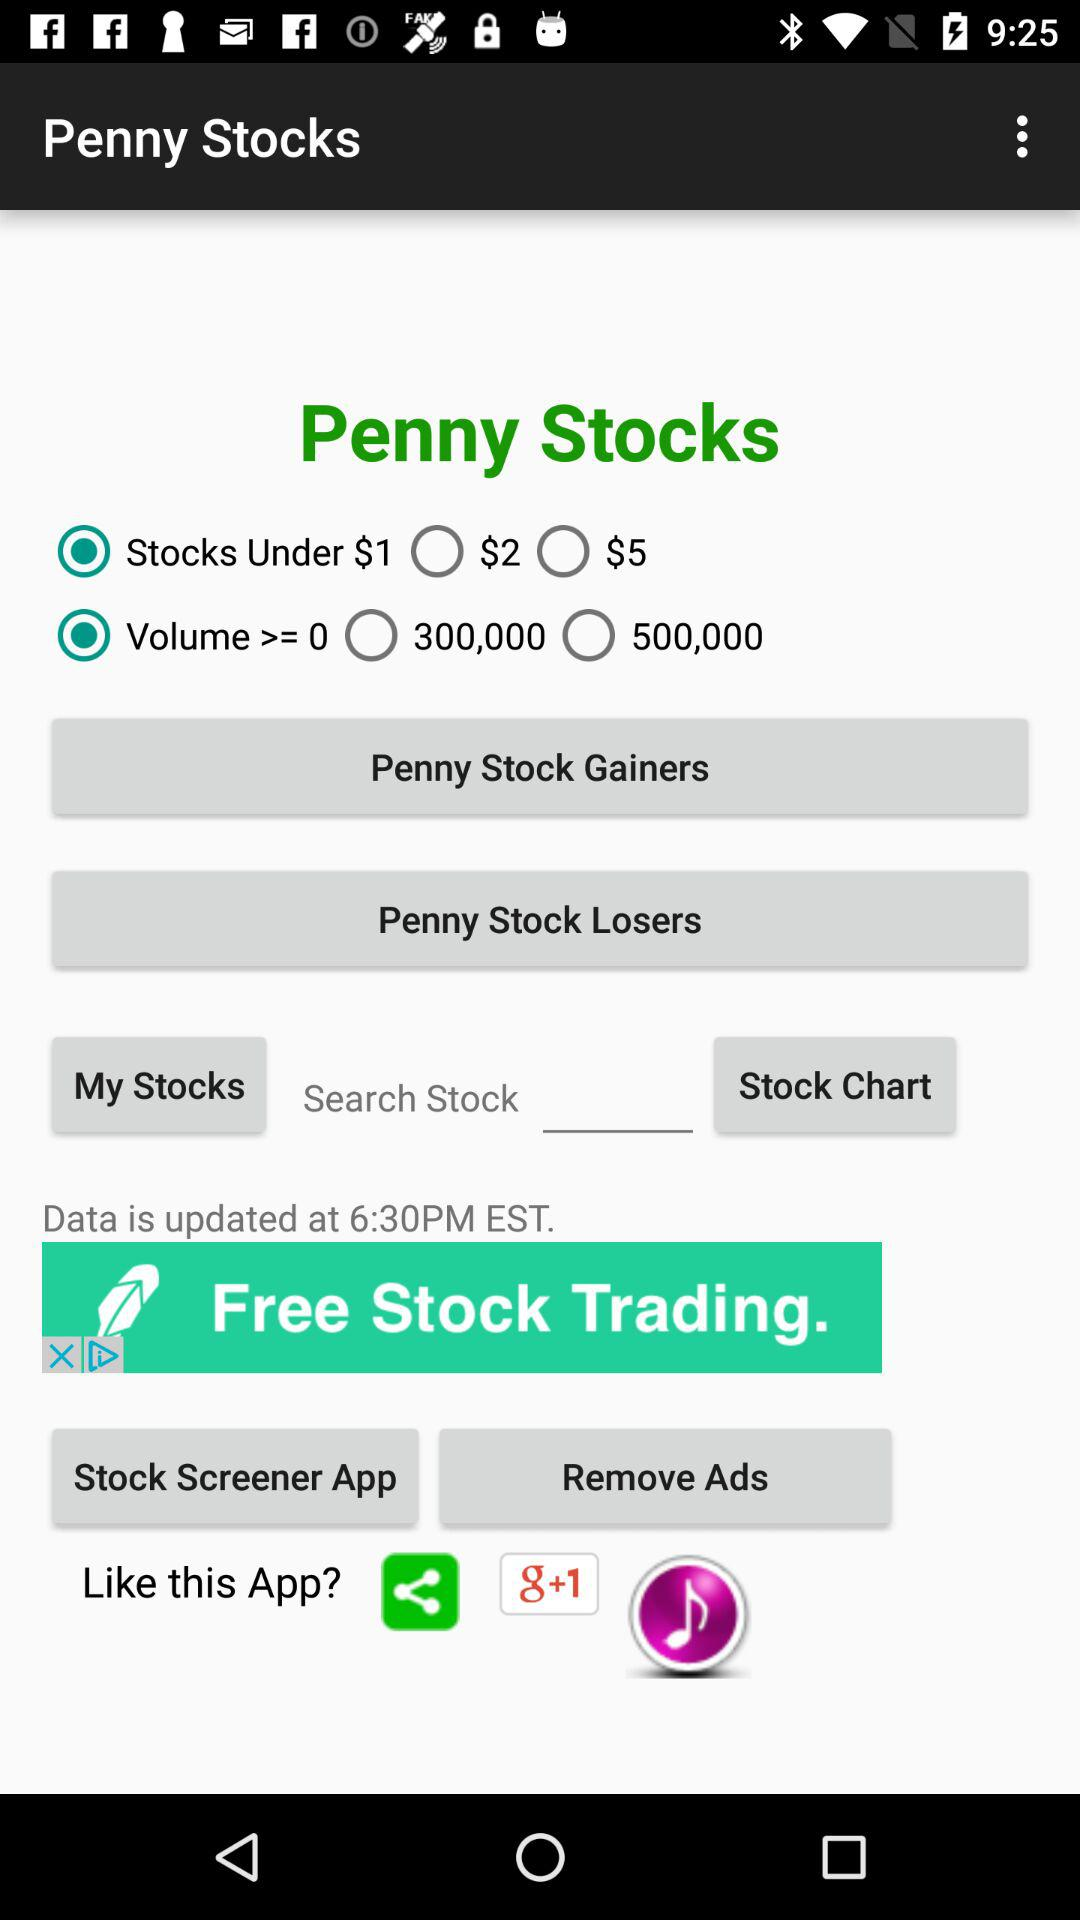What is the application name? The application name is "Penny Stocks". 